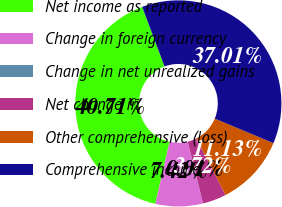Convert chart. <chart><loc_0><loc_0><loc_500><loc_500><pie_chart><fcel>Net income as reported<fcel>Change in foreign currency<fcel>Change in net unrealized gains<fcel>Net change in<fcel>Other comprehensive (loss)<fcel>Comprehensive income<nl><fcel>40.71%<fcel>7.42%<fcel>0.01%<fcel>3.72%<fcel>11.13%<fcel>37.01%<nl></chart> 